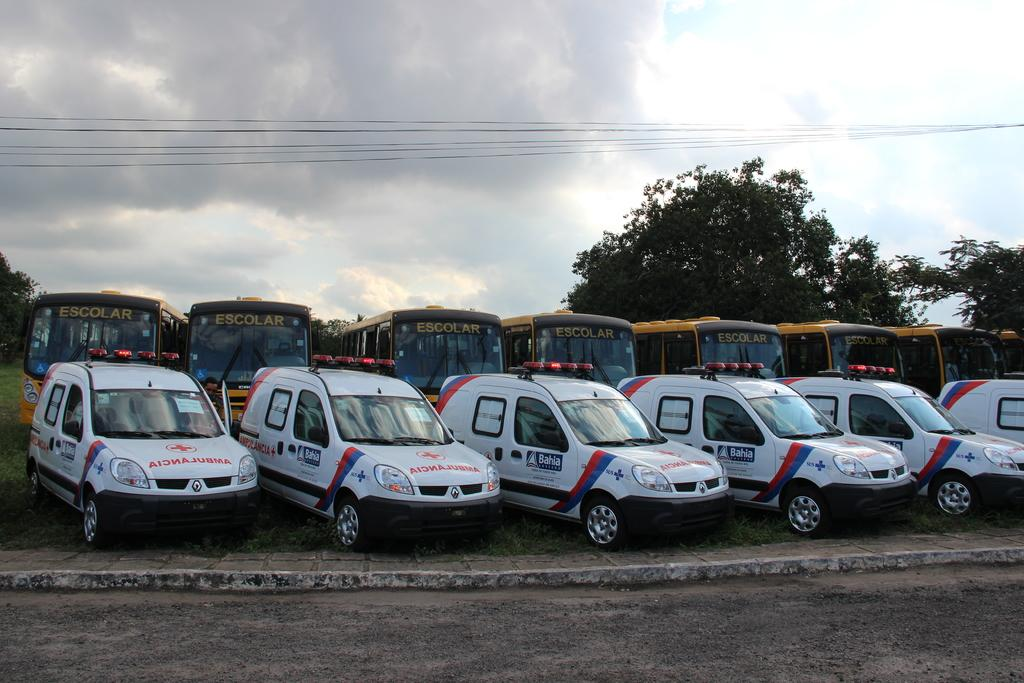What types of vehicles are present in the image? There are cars and buses in the image. What else can be seen in the image besides vehicles? There are trees and sky visible in the image. What is the surface at the bottom of the image? There is a road at the bottom of the image. Where is the crowd gathered in the image? There is no crowd present in the image. What is the hammer being used for in the image? There is no hammer present in the image. 